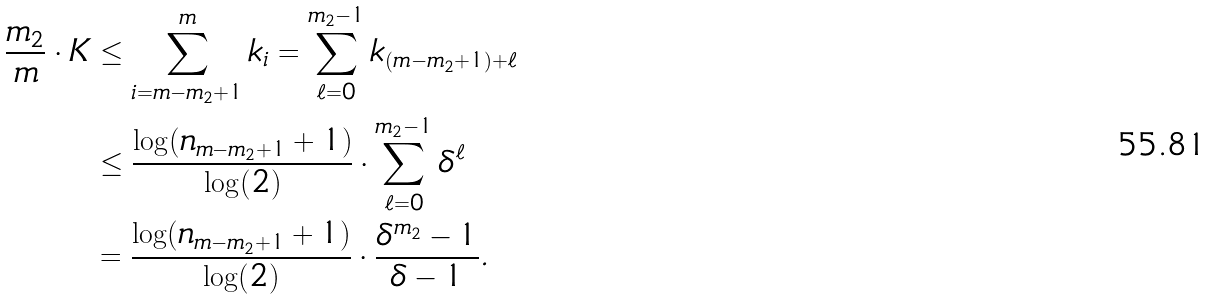Convert formula to latex. <formula><loc_0><loc_0><loc_500><loc_500>\frac { m _ { 2 } } { m } \cdot K & \leq \sum _ { i = m - m _ { 2 } + 1 } ^ { m } k _ { i } = \sum _ { \ell = 0 } ^ { m _ { 2 } - 1 } k _ { ( m - m _ { 2 } + 1 ) + \ell } \\ & \leq \frac { \log ( n _ { m - m _ { 2 } + 1 } + 1 ) } { \log ( 2 ) } \cdot \sum _ { \ell = 0 } ^ { m _ { 2 } - 1 } \delta ^ { \ell } \\ & = \frac { \log ( n _ { m - m _ { 2 } + 1 } + 1 ) } { \log ( 2 ) } \cdot \frac { \delta ^ { m _ { 2 } } - 1 } { \delta - 1 } .</formula> 